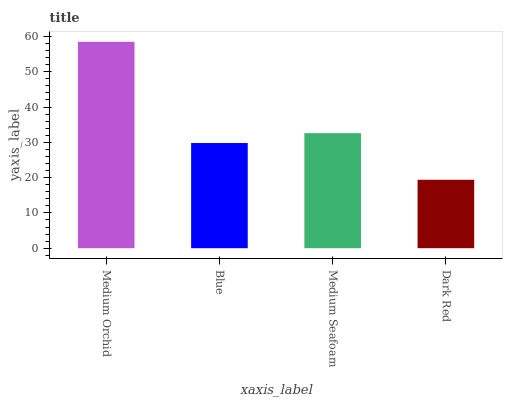Is Dark Red the minimum?
Answer yes or no. Yes. Is Medium Orchid the maximum?
Answer yes or no. Yes. Is Blue the minimum?
Answer yes or no. No. Is Blue the maximum?
Answer yes or no. No. Is Medium Orchid greater than Blue?
Answer yes or no. Yes. Is Blue less than Medium Orchid?
Answer yes or no. Yes. Is Blue greater than Medium Orchid?
Answer yes or no. No. Is Medium Orchid less than Blue?
Answer yes or no. No. Is Medium Seafoam the high median?
Answer yes or no. Yes. Is Blue the low median?
Answer yes or no. Yes. Is Medium Orchid the high median?
Answer yes or no. No. Is Medium Seafoam the low median?
Answer yes or no. No. 